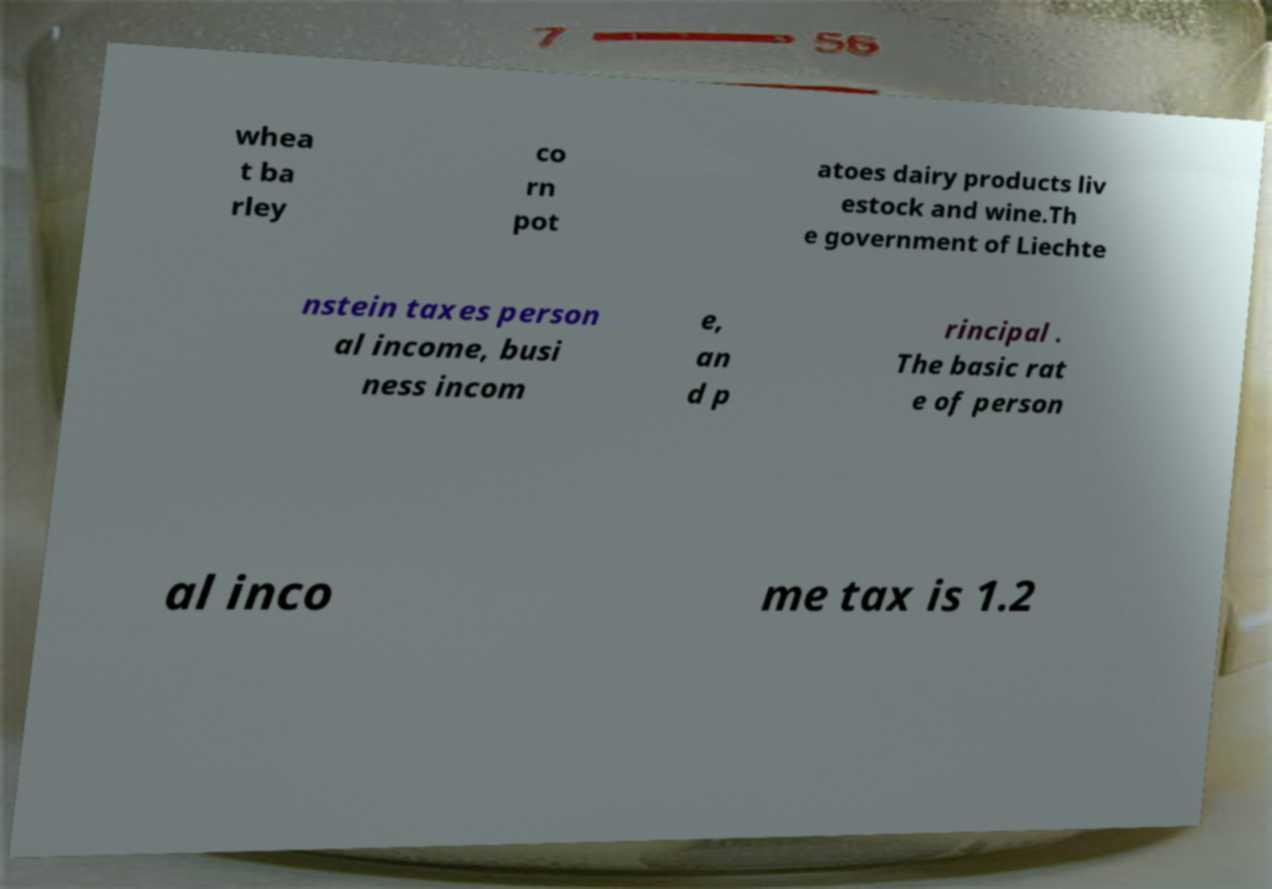Could you extract and type out the text from this image? whea t ba rley co rn pot atoes dairy products liv estock and wine.Th e government of Liechte nstein taxes person al income, busi ness incom e, an d p rincipal . The basic rat e of person al inco me tax is 1.2 